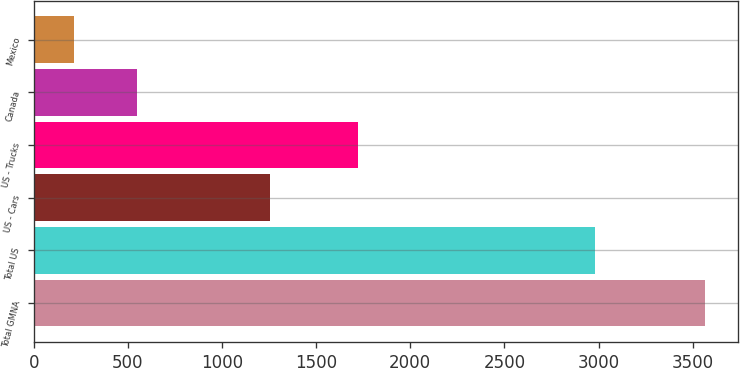Convert chart to OTSL. <chart><loc_0><loc_0><loc_500><loc_500><bar_chart><fcel>Total GMNA<fcel>Total US<fcel>US - Cars<fcel>US - Trucks<fcel>Canada<fcel>Mexico<nl><fcel>3565<fcel>2981<fcel>1257<fcel>1723<fcel>547.3<fcel>212<nl></chart> 